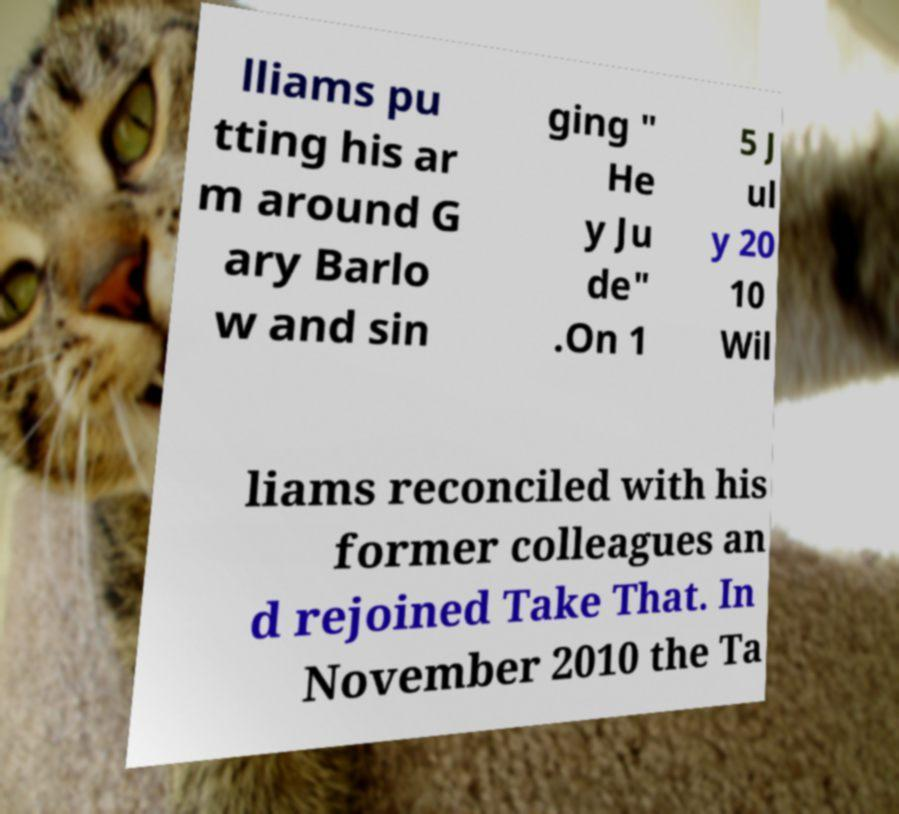What messages or text are displayed in this image? I need them in a readable, typed format. lliams pu tting his ar m around G ary Barlo w and sin ging " He y Ju de" .On 1 5 J ul y 20 10 Wil liams reconciled with his former colleagues an d rejoined Take That. In November 2010 the Ta 